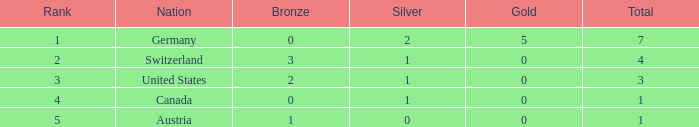What is the full amount of Total for Austria when the number of gold is less than 0? None. 